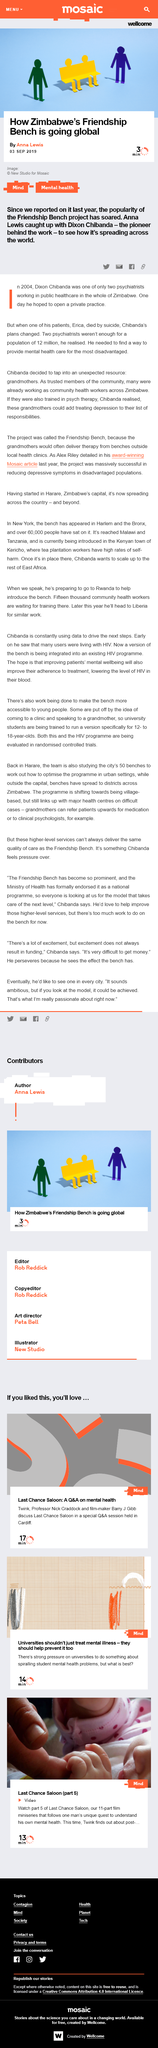Mention a couple of crucial points in this snapshot. In 2004, only two psychiatrists were employed in the entire public healthcare system of Zimbabwe. Dixon Chibanda's life was catalyzed by the suicide of one of his patients, which prompted him to dedicate his efforts to providing mental health care for the most disadvantaged. Dixon Chibanda is the pioneer behind the development of the friendship bench in Zimbabwe. 